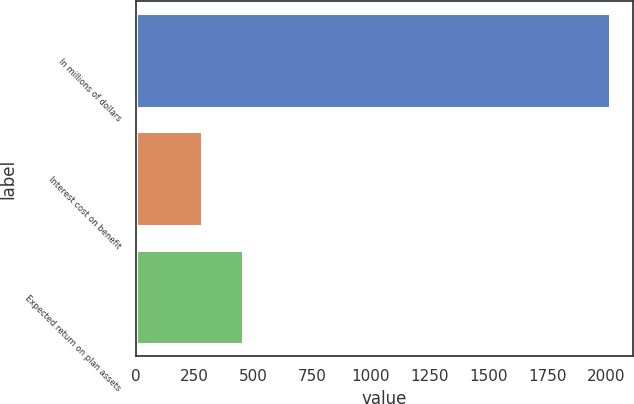Convert chart. <chart><loc_0><loc_0><loc_500><loc_500><bar_chart><fcel>In millions of dollars<fcel>Interest cost on benefit<fcel>Expected return on plan assets<nl><fcel>2016<fcel>282<fcel>455.4<nl></chart> 